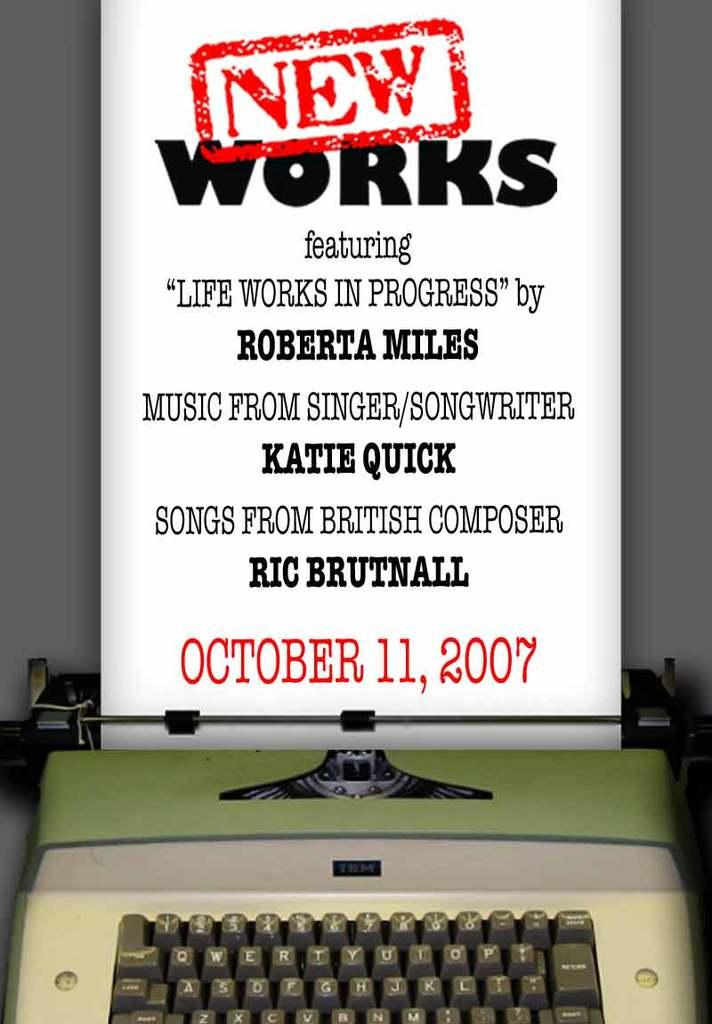<image>
Present a compact description of the photo's key features. Typewriter with an ad above it that says "New Works". 